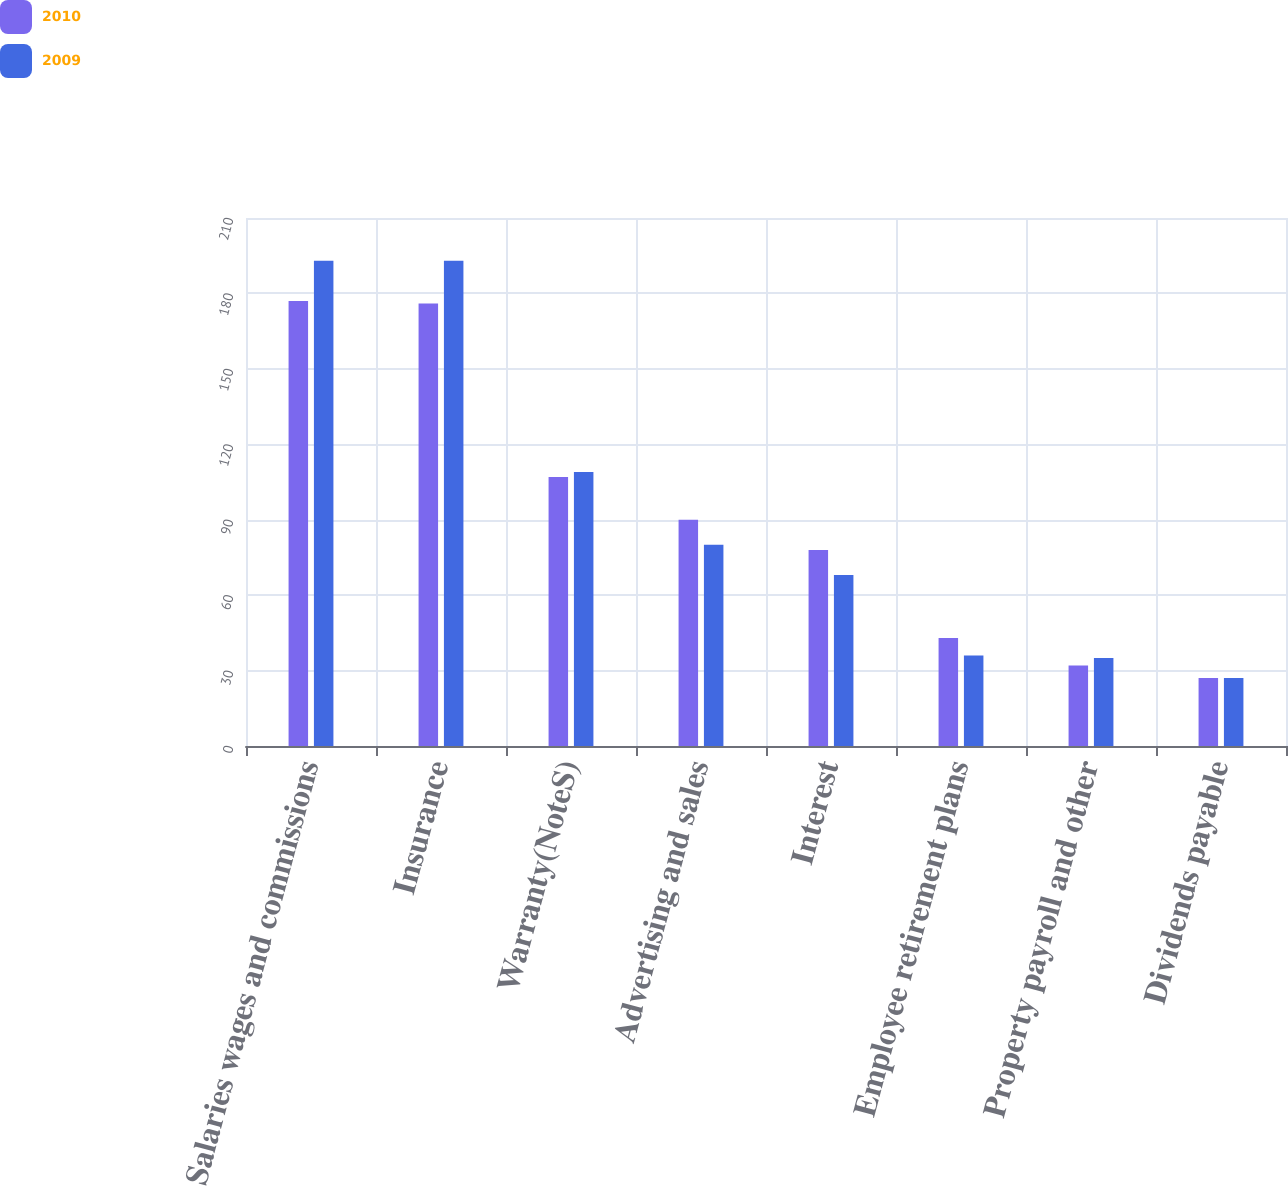Convert chart. <chart><loc_0><loc_0><loc_500><loc_500><stacked_bar_chart><ecel><fcel>Salaries wages and commissions<fcel>Insurance<fcel>Warranty(NoteS)<fcel>Advertising and sales<fcel>Interest<fcel>Employee retirement plans<fcel>Property payroll and other<fcel>Dividends payable<nl><fcel>2010<fcel>177<fcel>176<fcel>107<fcel>90<fcel>78<fcel>43<fcel>32<fcel>27<nl><fcel>2009<fcel>193<fcel>193<fcel>109<fcel>80<fcel>68<fcel>36<fcel>35<fcel>27<nl></chart> 